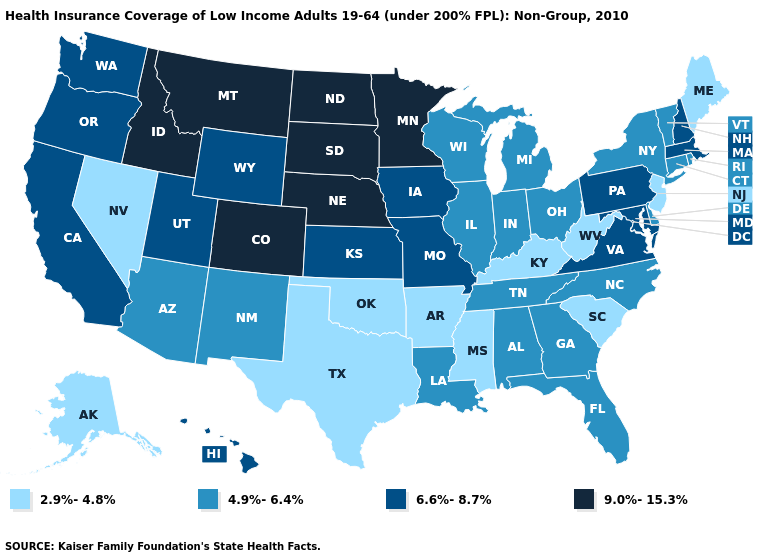What is the value of Washington?
Quick response, please. 6.6%-8.7%. Name the states that have a value in the range 2.9%-4.8%?
Quick response, please. Alaska, Arkansas, Kentucky, Maine, Mississippi, Nevada, New Jersey, Oklahoma, South Carolina, Texas, West Virginia. What is the value of Idaho?
Give a very brief answer. 9.0%-15.3%. Among the states that border Massachusetts , does Connecticut have the highest value?
Concise answer only. No. Which states have the highest value in the USA?
Concise answer only. Colorado, Idaho, Minnesota, Montana, Nebraska, North Dakota, South Dakota. Among the states that border Wisconsin , which have the lowest value?
Give a very brief answer. Illinois, Michigan. Does South Dakota have the highest value in the USA?
Short answer required. Yes. What is the highest value in the USA?
Quick response, please. 9.0%-15.3%. What is the value of Georgia?
Give a very brief answer. 4.9%-6.4%. Does Nevada have the lowest value in the West?
Short answer required. Yes. Among the states that border Missouri , which have the highest value?
Short answer required. Nebraska. What is the value of Kentucky?
Short answer required. 2.9%-4.8%. What is the value of Missouri?
Give a very brief answer. 6.6%-8.7%. Name the states that have a value in the range 2.9%-4.8%?
Keep it brief. Alaska, Arkansas, Kentucky, Maine, Mississippi, Nevada, New Jersey, Oklahoma, South Carolina, Texas, West Virginia. Does New Hampshire have the highest value in the USA?
Keep it brief. No. 